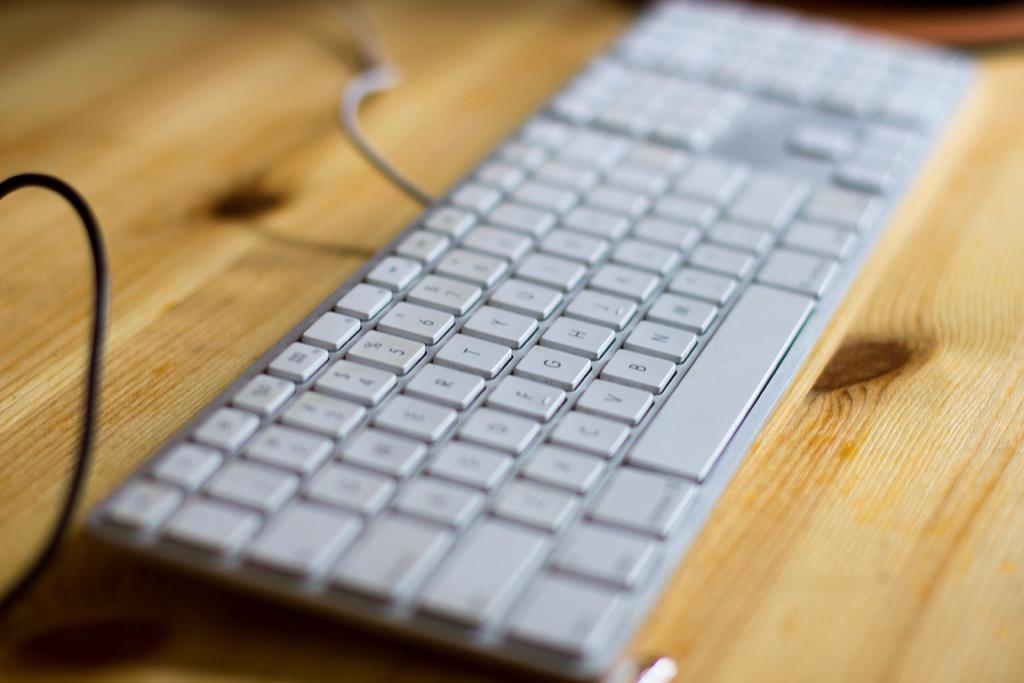<image>
Create a compact narrative representing the image presented. The keyboard B key is right next to the V key 